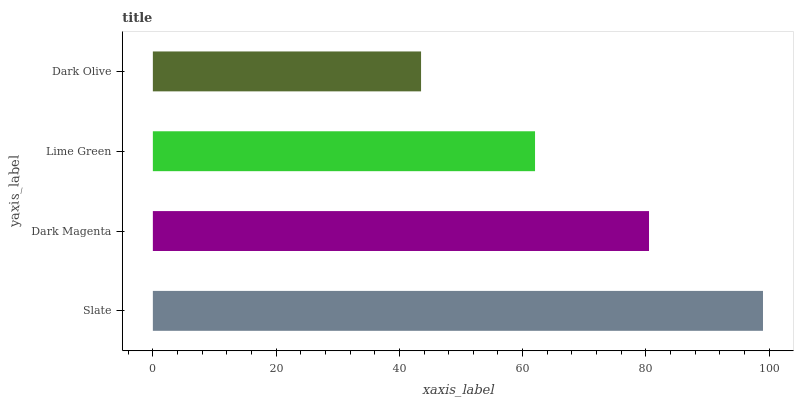Is Dark Olive the minimum?
Answer yes or no. Yes. Is Slate the maximum?
Answer yes or no. Yes. Is Dark Magenta the minimum?
Answer yes or no. No. Is Dark Magenta the maximum?
Answer yes or no. No. Is Slate greater than Dark Magenta?
Answer yes or no. Yes. Is Dark Magenta less than Slate?
Answer yes or no. Yes. Is Dark Magenta greater than Slate?
Answer yes or no. No. Is Slate less than Dark Magenta?
Answer yes or no. No. Is Dark Magenta the high median?
Answer yes or no. Yes. Is Lime Green the low median?
Answer yes or no. Yes. Is Lime Green the high median?
Answer yes or no. No. Is Dark Olive the low median?
Answer yes or no. No. 